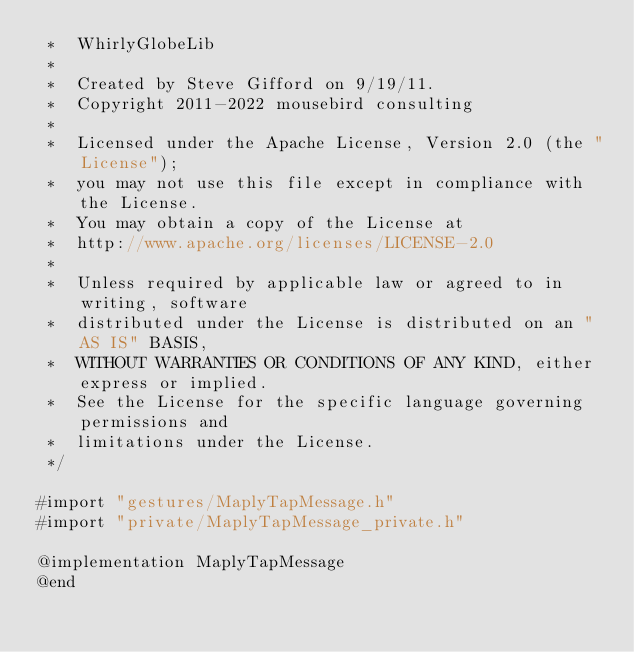<code> <loc_0><loc_0><loc_500><loc_500><_ObjectiveC_> *  WhirlyGlobeLib
 *
 *  Created by Steve Gifford on 9/19/11.
 *  Copyright 2011-2022 mousebird consulting
 *
 *  Licensed under the Apache License, Version 2.0 (the "License");
 *  you may not use this file except in compliance with the License.
 *  You may obtain a copy of the License at
 *  http://www.apache.org/licenses/LICENSE-2.0
 *
 *  Unless required by applicable law or agreed to in writing, software
 *  distributed under the License is distributed on an "AS IS" BASIS,
 *  WITHOUT WARRANTIES OR CONDITIONS OF ANY KIND, either express or implied.
 *  See the License for the specific language governing permissions and
 *  limitations under the License.
 */

#import "gestures/MaplyTapMessage.h"
#import "private/MaplyTapMessage_private.h"

@implementation MaplyTapMessage
@end
</code> 